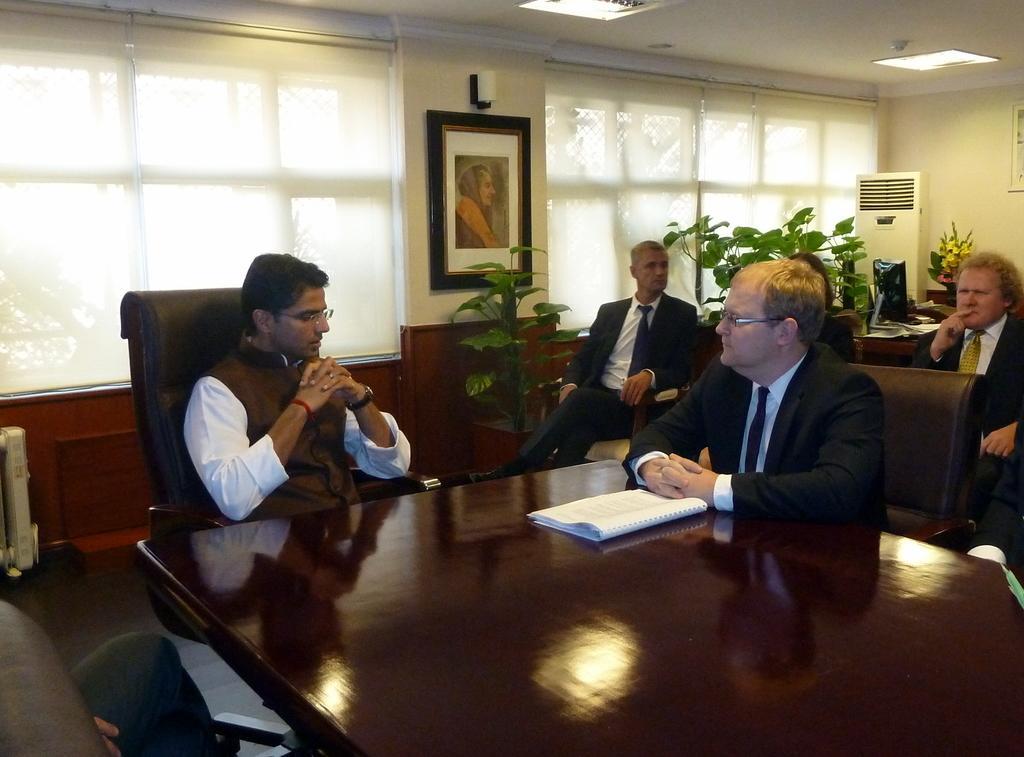Please provide a concise description of this image. This picture shows the inner view of a building, two lights attached to the ceiling, two objects attached to the walls, two curtains attached to the windows, two tables, two objects attached to the ceiling, some chairs, one photo frame attached to the wall, some plants with pots, some people are sitting on the chairs, one computer, one white object looks like an air cooler, two objects on the floor and some objects on the tables. 